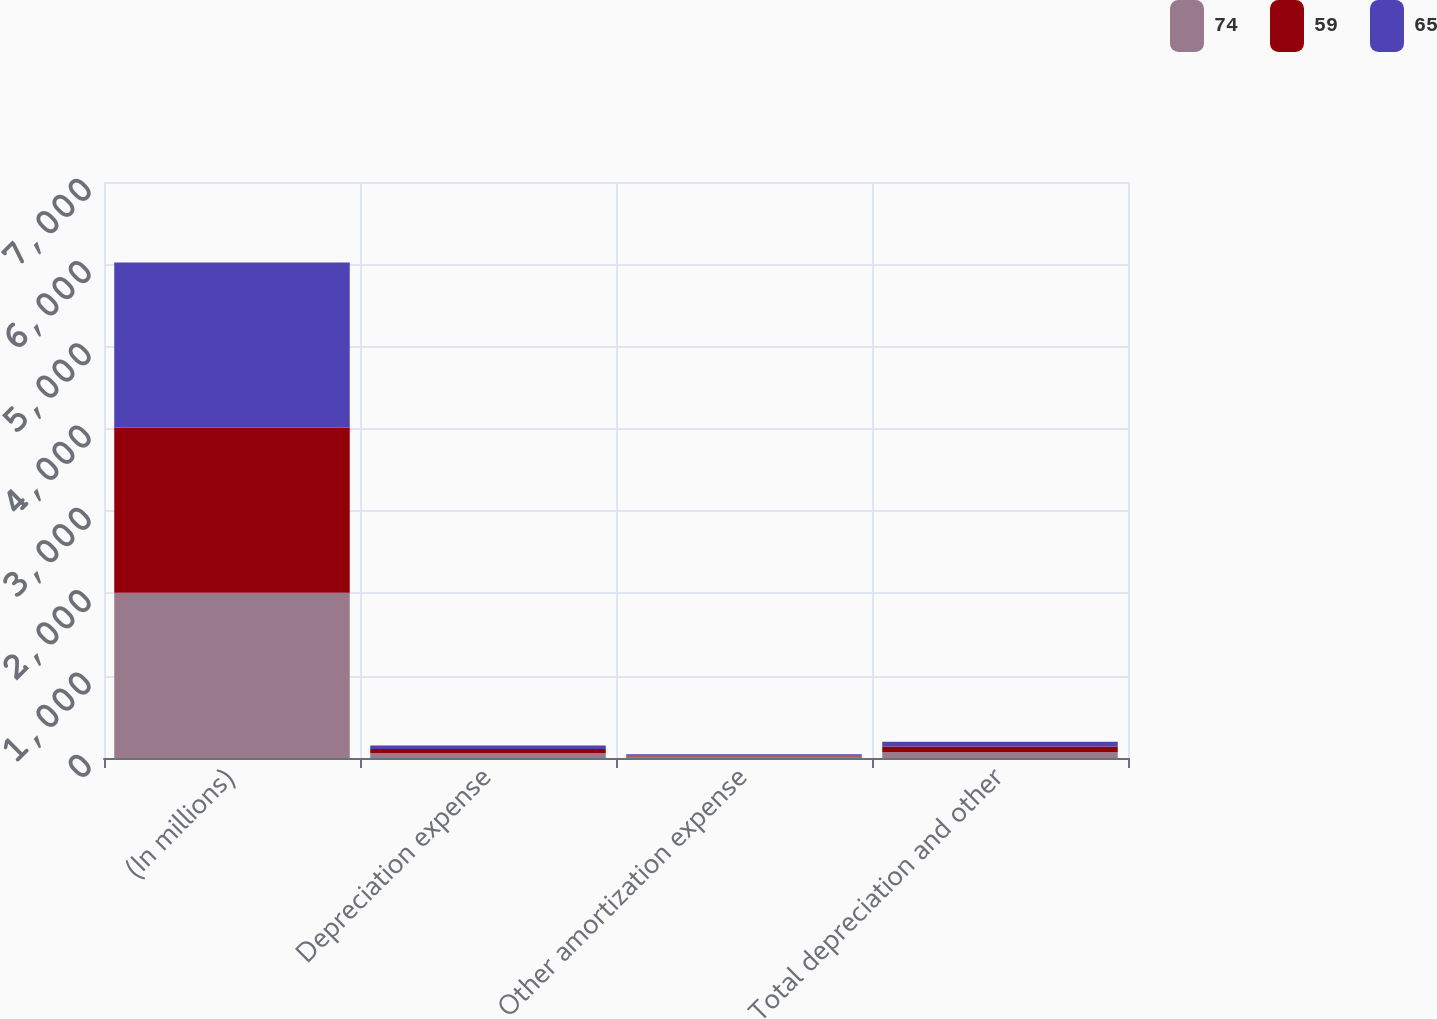Convert chart to OTSL. <chart><loc_0><loc_0><loc_500><loc_500><stacked_bar_chart><ecel><fcel>(In millions)<fcel>Depreciation expense<fcel>Other amortization expense<fcel>Total depreciation and other<nl><fcel>74<fcel>2008<fcel>57<fcel>17<fcel>74<nl><fcel>59<fcel>2007<fcel>51<fcel>14<fcel>65<nl><fcel>65<fcel>2006<fcel>44<fcel>15<fcel>59<nl></chart> 